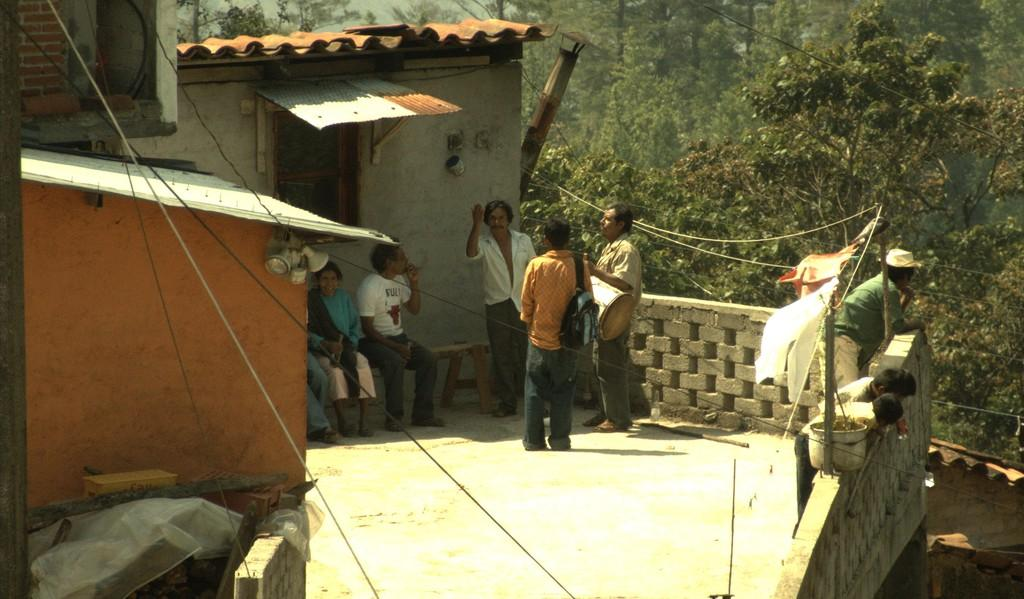What are the people in the image doing? There are people sitting and standing in the image. What are some of the people holding? Some people are holding bags, while others are holding unspecified objects. What type of structures can be seen in the image? There are houses in the image. What architectural features are present in the image? There are windows and fencing visible in the image. What type of vegetation is present in the image? There are trees in the image. What objects can be seen on the floor in the image? There are objects on the floor in the image. How many girls are sitting on the spiders in the image? There are no spiders or girls present in the image. 